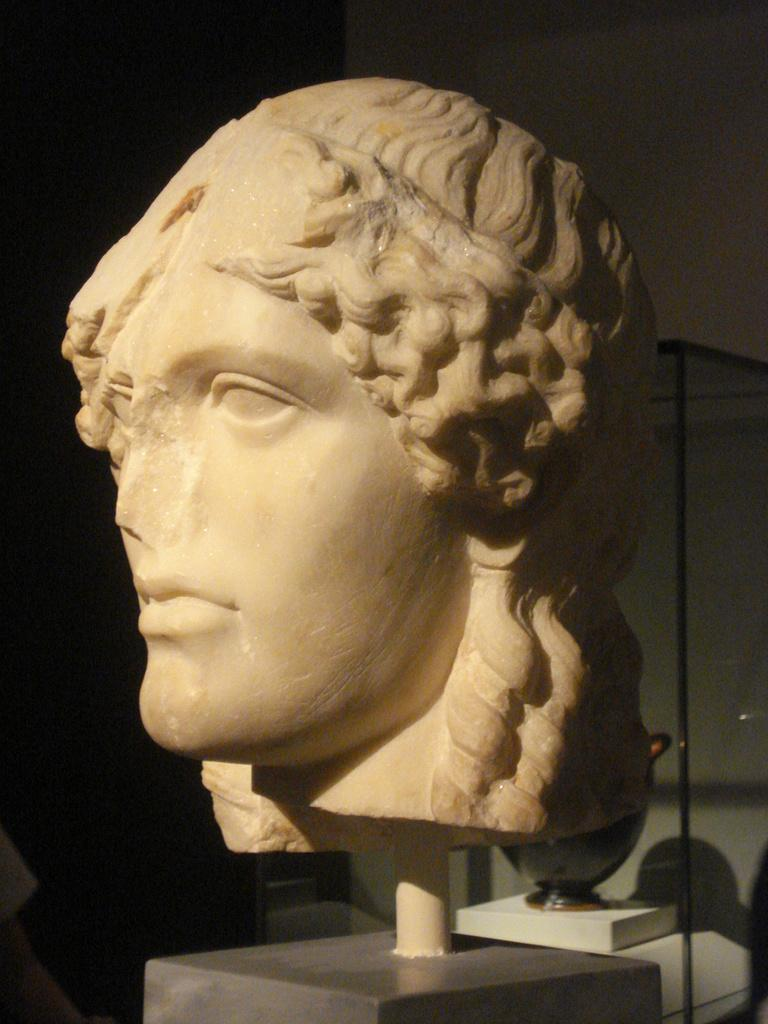What is the main subject in the center of the image? There is a statue in the center of the image. What can be seen in the background of the image? There is a wall and glass in the background of the image. Are there any other objects visible in the background? Yes, there is an object in the background of the image. What type of board is being used by the coach in the image? There is no board or coach present in the image; it features a statue and a background with a wall and glass. 